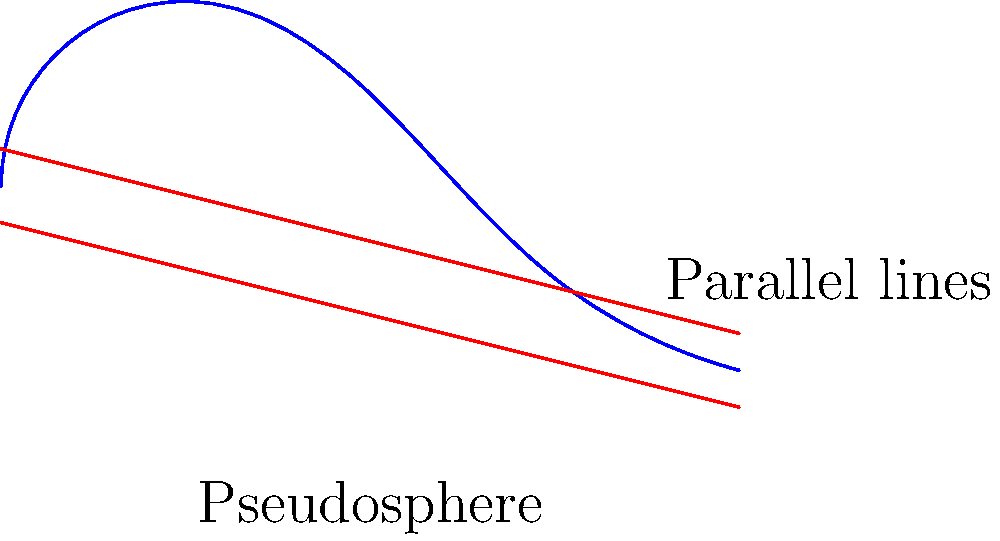In the context of Non-Euclidean Geometry, consider two parallel lines on a saddle-shaped surface (pseudosphere) as shown in the diagram. How does the behavior of these lines differ from parallel lines in Euclidean geometry, and what implications might this have for political boundaries in French Polynesia's complex island geography? To understand the behavior of parallel lines on a pseudosphere and its implications for French Polynesia's political boundaries, let's follow these steps:

1. Non-Euclidean Geometry on a Pseudosphere:
   - A pseudosphere is a surface with constant negative curvature.
   - In Non-Euclidean Geometry, the behavior of parallel lines differs from Euclidean geometry.

2. Behavior of Parallel Lines:
   - On a pseudosphere, parallel lines appear to diverge as they extend.
   - This is in contrast to Euclidean geometry, where parallel lines maintain a constant distance.
   - The divergence is due to the negative curvature of the pseudosphere.

3. Mathematical Representation:
   - In hyperbolic geometry (applicable to pseudospheres), the distance $d$ between two initially parallel geodesics increases exponentially with length $l$:
     $$d \approx Ce^l$$
   where $C$ is a constant and $e$ is the base of natural logarithms.

4. Implications for French Polynesia:
   - French Polynesia consists of multiple islands spread across a vast oceanic area.
   - The curved nature of the Earth's surface becomes more pronounced over large distances.
   - Political boundaries that may appear parallel near one island could diverge significantly when extended to other islands.

5. Political and Historical Considerations:
   - Traditional Polynesian navigation considered the curvature of the Earth and celestial observations.
   - Modern political boundaries might need to account for the Non-Euclidean nature of the Earth's surface.
   - Historical treaties and agreements may need reinterpretation in light of more accurate geographical understanding.

6. Practical Applications:
   - Maritime boundaries between French Polynesia and neighboring countries may be affected.
   - Resource management and economic zones could be impacted by the divergence of seemingly parallel boundaries.
   - Navigation and cartography in the region must account for these Non-Euclidean properties.

This Non-Euclidean perspective provides a unique lens through which to view French Polynesia's political geography and history, potentially influencing modern governance and international relations in the region.
Answer: Parallel lines diverge on a pseudosphere, potentially affecting French Polynesia's maritime boundaries and political geography. 